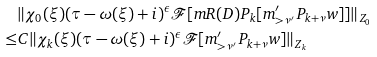Convert formula to latex. <formula><loc_0><loc_0><loc_500><loc_500>& \| \chi _ { 0 } ( \xi ) ( \tau - \omega ( \xi ) + i ) ^ { \epsilon } \mathcal { F } [ m R ( D ) P _ { k } [ m ^ { \prime } _ { > \nu ^ { \prime } } P _ { k + \nu } w ] ] \| _ { Z _ { 0 } } \\ \leq & C \| \chi _ { k } ( \xi ) ( \tau - \omega ( \xi ) + i ) ^ { \epsilon } \mathcal { F } [ m ^ { \prime } _ { > \nu ^ { \prime } } P _ { k + \nu } w ] \| _ { Z _ { k } }</formula> 